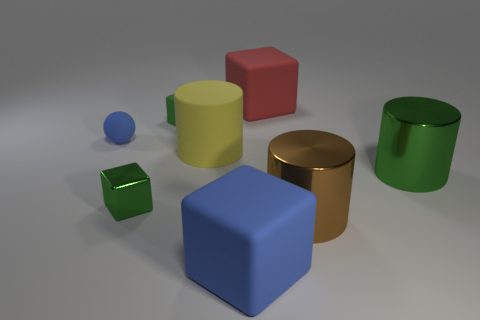Do the small metallic object and the object that is in front of the big brown cylinder have the same shape?
Give a very brief answer. Yes. What number of tiny objects are in front of the tiny blue rubber sphere and behind the small green metal cube?
Provide a succinct answer. 0. What number of red objects are either rubber objects or matte cubes?
Offer a terse response. 1. There is a cylinder to the left of the blue matte cube; is it the same color as the big thing that is behind the small rubber block?
Offer a very short reply. No. What is the color of the large matte block in front of the metallic object left of the blue thing on the right side of the ball?
Offer a terse response. Blue. There is a blue thing on the left side of the yellow cylinder; are there any red blocks that are left of it?
Offer a terse response. No. Does the blue thing on the right side of the metallic block have the same shape as the yellow matte thing?
Keep it short and to the point. No. Are there any other things that are the same shape as the small blue matte thing?
Ensure brevity in your answer.  No. How many balls are either green matte objects or big blue rubber things?
Give a very brief answer. 0. How many green rubber cubes are there?
Your answer should be very brief. 1. 